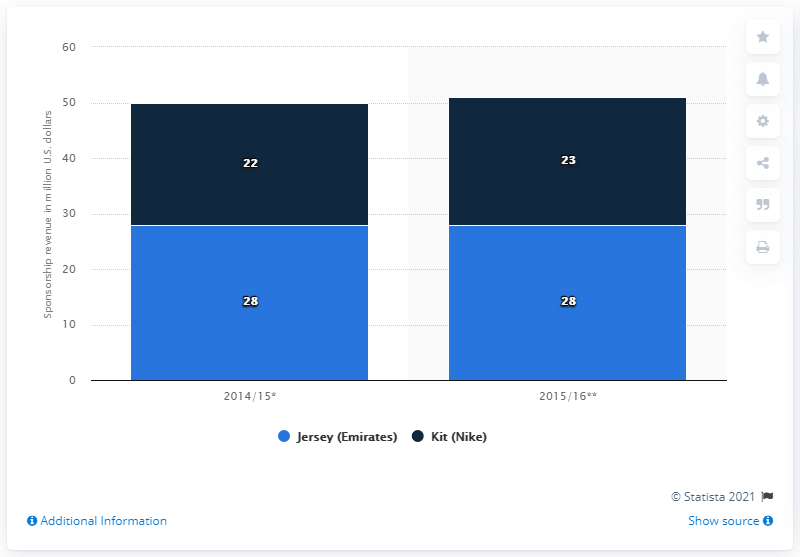Give some essential details in this illustration. The amount of sponsorship revenue for Paris Saint-Germain's kit in 2014/15 was 22.. 